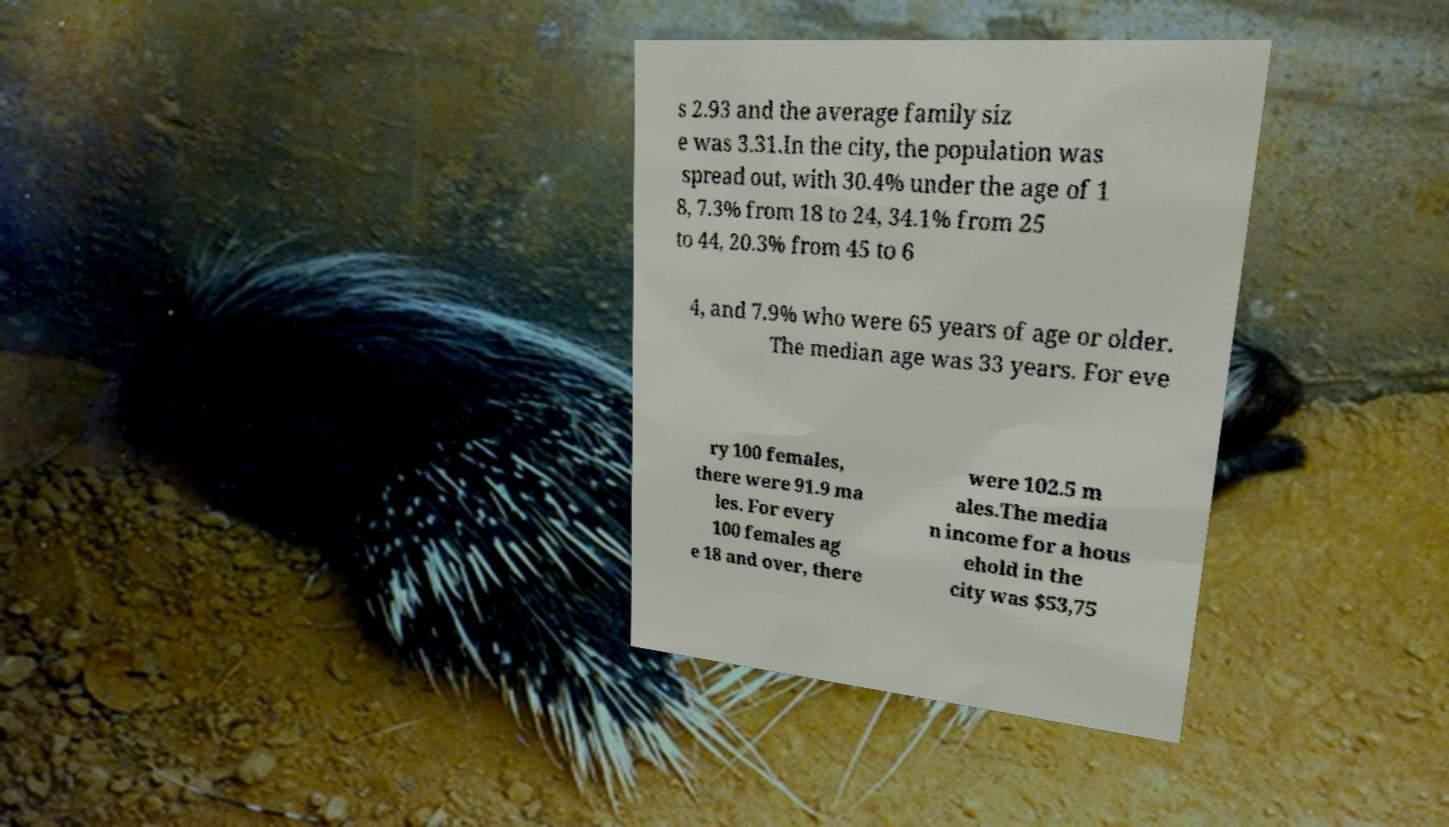What messages or text are displayed in this image? I need them in a readable, typed format. s 2.93 and the average family siz e was 3.31.In the city, the population was spread out, with 30.4% under the age of 1 8, 7.3% from 18 to 24, 34.1% from 25 to 44, 20.3% from 45 to 6 4, and 7.9% who were 65 years of age or older. The median age was 33 years. For eve ry 100 females, there were 91.9 ma les. For every 100 females ag e 18 and over, there were 102.5 m ales.The media n income for a hous ehold in the city was $53,75 